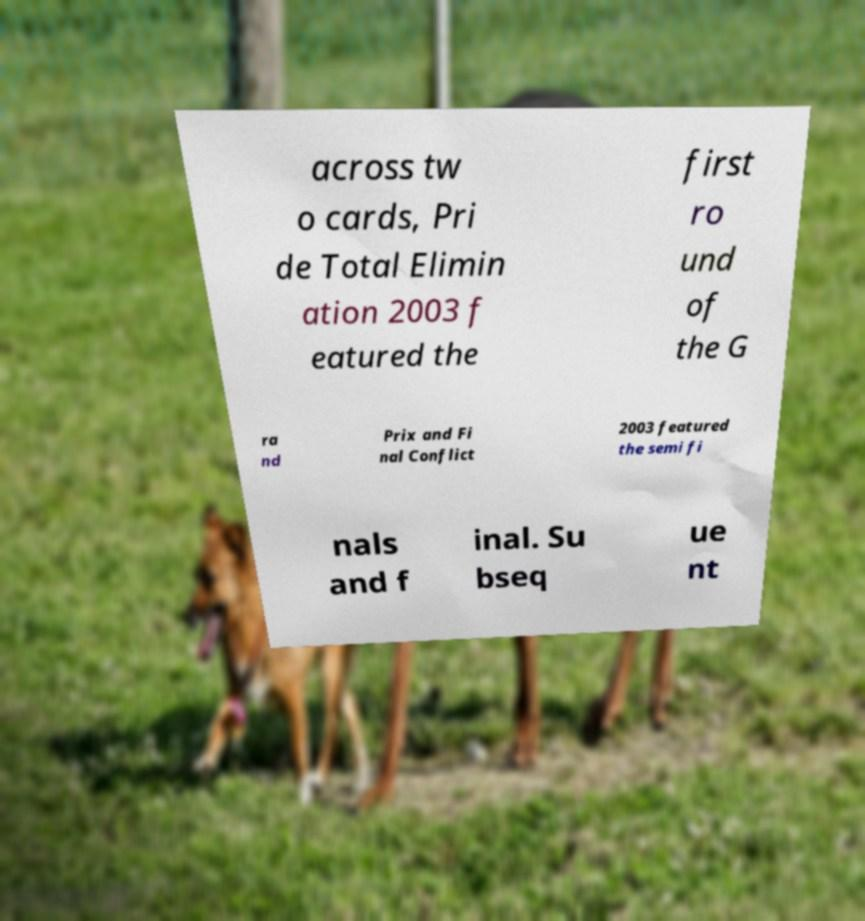There's text embedded in this image that I need extracted. Can you transcribe it verbatim? across tw o cards, Pri de Total Elimin ation 2003 f eatured the first ro und of the G ra nd Prix and Fi nal Conflict 2003 featured the semi fi nals and f inal. Su bseq ue nt 